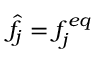<formula> <loc_0><loc_0><loc_500><loc_500>\hat { f } _ { j } = f _ { j } ^ { e q }</formula> 